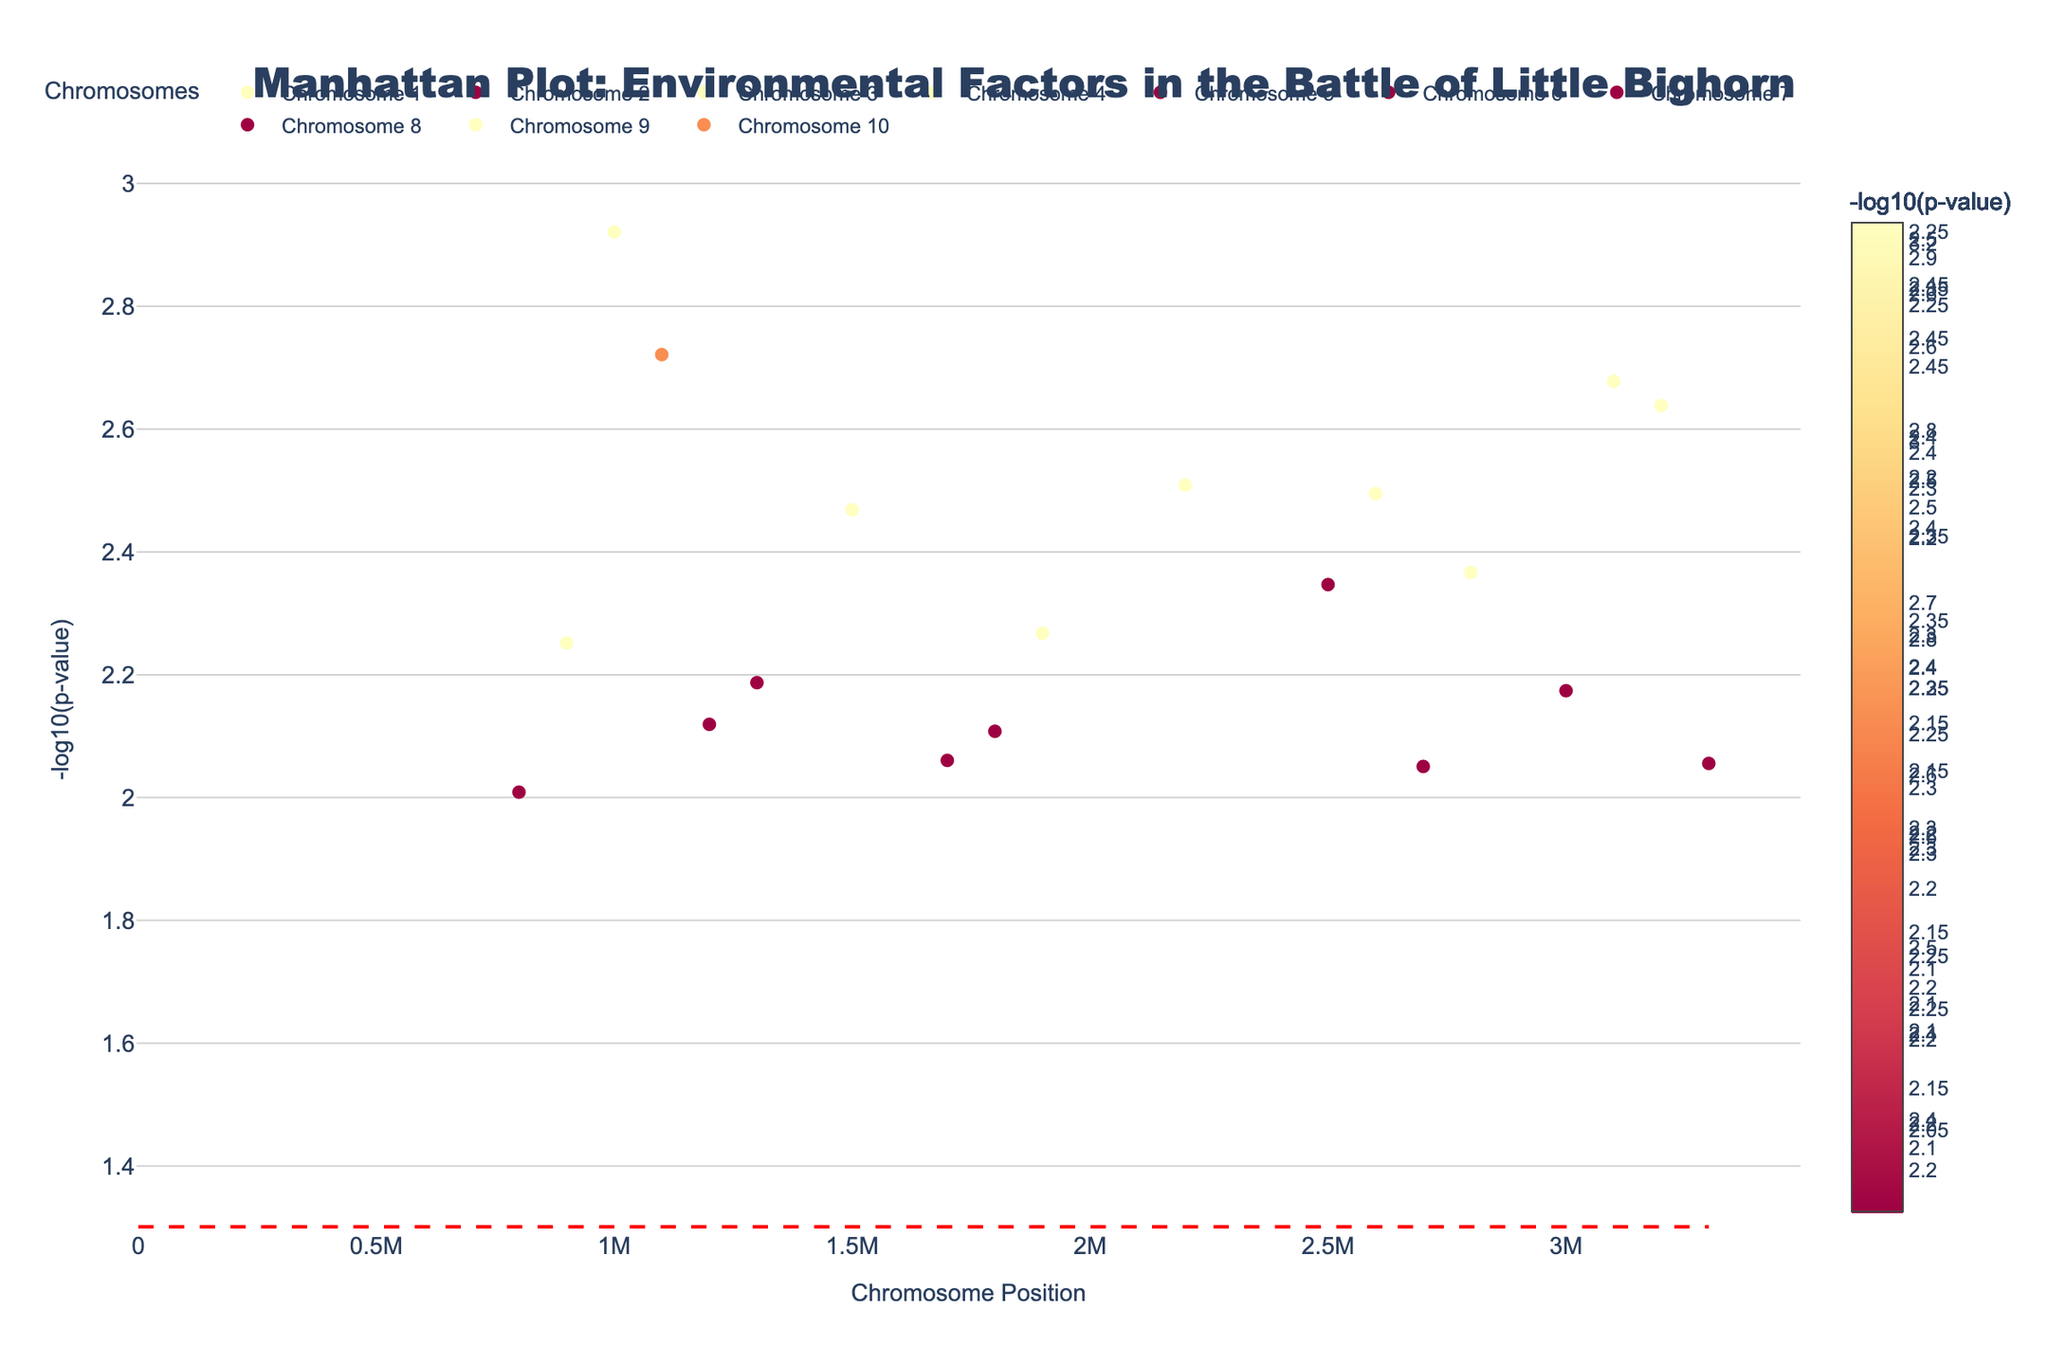What's the title of the plot? The title can be seen prominently displayed at the top of the plot and reads: "Manhattan Plot: Environmental Factors in the Battle of Little Bighorn".
Answer: Manhattan Plot: Environmental Factors in the Battle of Little Bighorn What is represented on the y-axis? The y-axis title "–log10(p-value)" indicates it represents the negative logarithm of P-values, which measures the statistical significance of environmental factors.
Answer: –log10(p-value) Which environmental factor has the highest significance on Chromosome 6? By examining the y-axis values (–log10(p-value)) for Chromosome 6, the point with the highest y-value indicates the most significant environmental factor, which is "Pollen_Count".
Answer: Pollen_Count What is the significance threshold line displayed on the plot? The horizontal red dashed line on the plot represents the commonly used significance threshold, which is at –log10(0.05).
Answer: –log10(0.05) How many data points have a p-value less than 0.05? Data points above the significance threshold line indicate p-values less than 0.05. By counting these points, we find there are five such data points.
Answer: Five Which chromosomes have environmental factors with p-values less than 0.01? Chromosomes 1, 2, 4, 5, 7, and 10 have points above the significance line, indicating p-values less than 0.01.
Answer: Chromosomes 1, 2, 4, 5, 7, and 10 What is the y-value of the most significant data point on Chromosome 1? The highest point on Chromosome 1 represents the most significant data point with a y-value of around -log10(0.0012), which equals about 2.92.
Answer: 2.92 Compare the significance of "Precipitation" and "Visibility". Which is more significant? Comparing the y-values (–log10(p-value)) of "Precipitation" on Chromosome 1 and "Visibility" on Chromosome 4, "Precipitation" has a lower significance as its y-value is smaller (about 2.35 vs. 2.52).
Answer: Visibility Which chromosome has the greatest diversity of environmental factors tested? Counting the distinct environmental factors for each chromosome, Chromosomes 4, 5, 6, 7, and 8 each have two factors, showing the greatest diversity.
Answer: Chromosomes 4, 5, 6, 7, and 8 